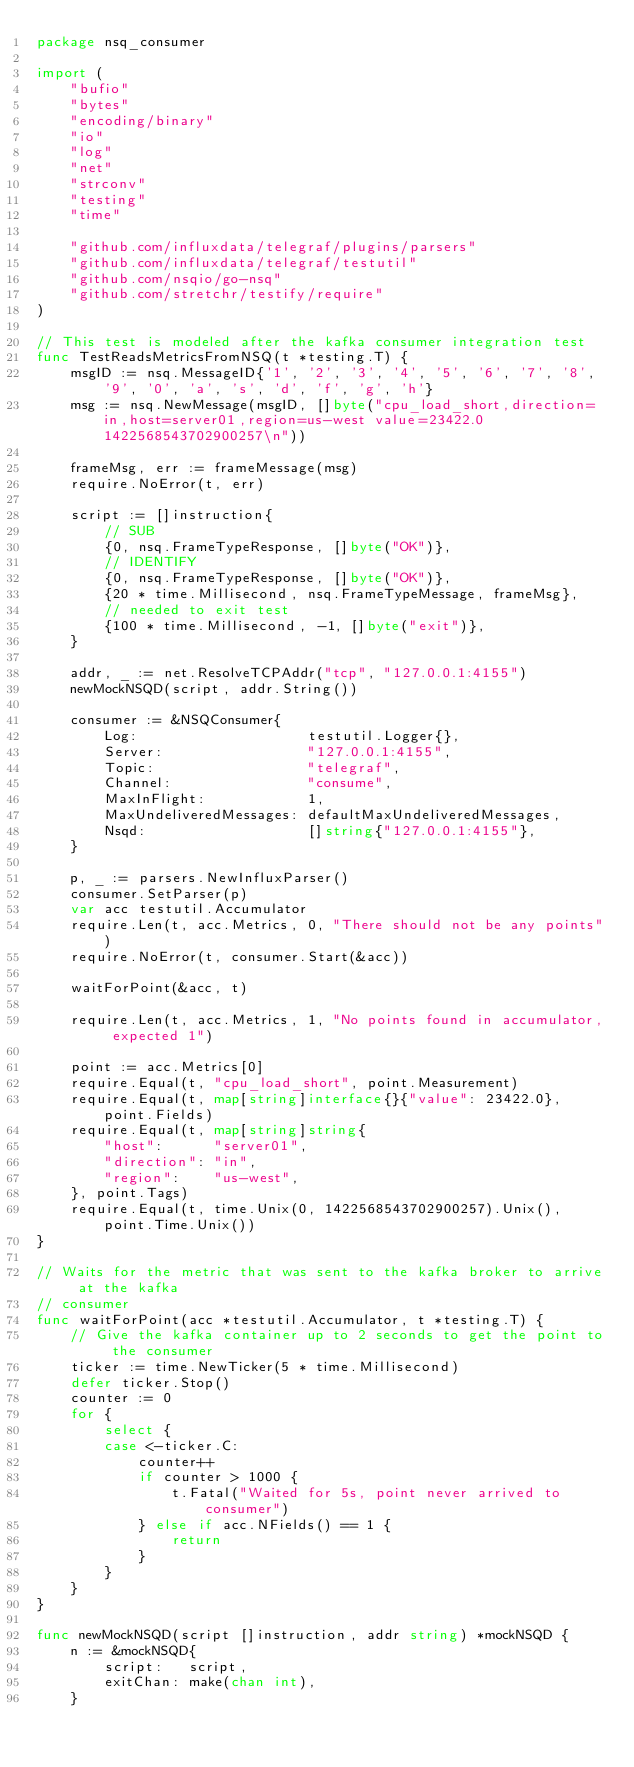Convert code to text. <code><loc_0><loc_0><loc_500><loc_500><_Go_>package nsq_consumer

import (
	"bufio"
	"bytes"
	"encoding/binary"
	"io"
	"log"
	"net"
	"strconv"
	"testing"
	"time"

	"github.com/influxdata/telegraf/plugins/parsers"
	"github.com/influxdata/telegraf/testutil"
	"github.com/nsqio/go-nsq"
	"github.com/stretchr/testify/require"
)

// This test is modeled after the kafka consumer integration test
func TestReadsMetricsFromNSQ(t *testing.T) {
	msgID := nsq.MessageID{'1', '2', '3', '4', '5', '6', '7', '8', '9', '0', 'a', 's', 'd', 'f', 'g', 'h'}
	msg := nsq.NewMessage(msgID, []byte("cpu_load_short,direction=in,host=server01,region=us-west value=23422.0 1422568543702900257\n"))

	frameMsg, err := frameMessage(msg)
	require.NoError(t, err)

	script := []instruction{
		// SUB
		{0, nsq.FrameTypeResponse, []byte("OK")},
		// IDENTIFY
		{0, nsq.FrameTypeResponse, []byte("OK")},
		{20 * time.Millisecond, nsq.FrameTypeMessage, frameMsg},
		// needed to exit test
		{100 * time.Millisecond, -1, []byte("exit")},
	}

	addr, _ := net.ResolveTCPAddr("tcp", "127.0.0.1:4155")
	newMockNSQD(script, addr.String())

	consumer := &NSQConsumer{
		Log:                    testutil.Logger{},
		Server:                 "127.0.0.1:4155",
		Topic:                  "telegraf",
		Channel:                "consume",
		MaxInFlight:            1,
		MaxUndeliveredMessages: defaultMaxUndeliveredMessages,
		Nsqd:                   []string{"127.0.0.1:4155"},
	}

	p, _ := parsers.NewInfluxParser()
	consumer.SetParser(p)
	var acc testutil.Accumulator
	require.Len(t, acc.Metrics, 0, "There should not be any points")
	require.NoError(t, consumer.Start(&acc))

	waitForPoint(&acc, t)

	require.Len(t, acc.Metrics, 1, "No points found in accumulator, expected 1")

	point := acc.Metrics[0]
	require.Equal(t, "cpu_load_short", point.Measurement)
	require.Equal(t, map[string]interface{}{"value": 23422.0}, point.Fields)
	require.Equal(t, map[string]string{
		"host":      "server01",
		"direction": "in",
		"region":    "us-west",
	}, point.Tags)
	require.Equal(t, time.Unix(0, 1422568543702900257).Unix(), point.Time.Unix())
}

// Waits for the metric that was sent to the kafka broker to arrive at the kafka
// consumer
func waitForPoint(acc *testutil.Accumulator, t *testing.T) {
	// Give the kafka container up to 2 seconds to get the point to the consumer
	ticker := time.NewTicker(5 * time.Millisecond)
	defer ticker.Stop()
	counter := 0
	for {
		select {
		case <-ticker.C:
			counter++
			if counter > 1000 {
				t.Fatal("Waited for 5s, point never arrived to consumer")
			} else if acc.NFields() == 1 {
				return
			}
		}
	}
}

func newMockNSQD(script []instruction, addr string) *mockNSQD {
	n := &mockNSQD{
		script:   script,
		exitChan: make(chan int),
	}
</code> 